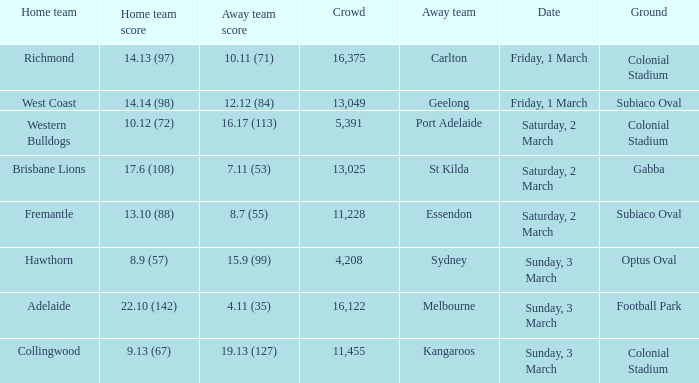Who is the away team when the home team scored 17.6 (108)? St Kilda. 